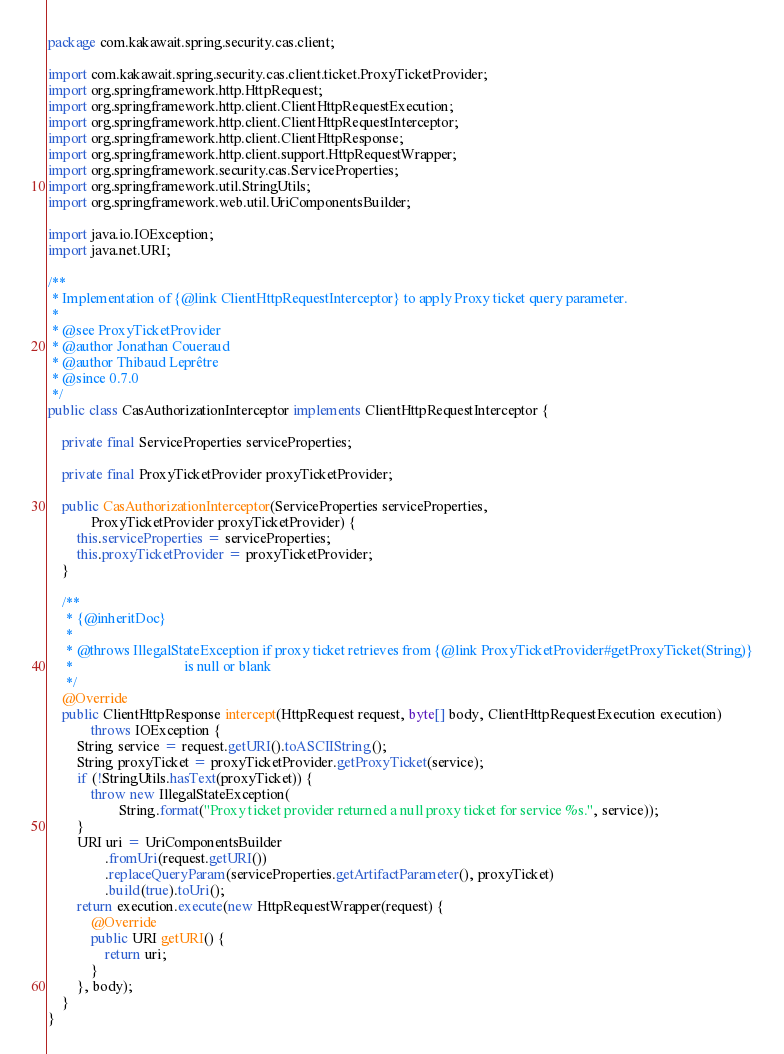<code> <loc_0><loc_0><loc_500><loc_500><_Java_>package com.kakawait.spring.security.cas.client;

import com.kakawait.spring.security.cas.client.ticket.ProxyTicketProvider;
import org.springframework.http.HttpRequest;
import org.springframework.http.client.ClientHttpRequestExecution;
import org.springframework.http.client.ClientHttpRequestInterceptor;
import org.springframework.http.client.ClientHttpResponse;
import org.springframework.http.client.support.HttpRequestWrapper;
import org.springframework.security.cas.ServiceProperties;
import org.springframework.util.StringUtils;
import org.springframework.web.util.UriComponentsBuilder;

import java.io.IOException;
import java.net.URI;

/**
 * Implementation of {@link ClientHttpRequestInterceptor} to apply Proxy ticket query parameter.
 *
 * @see ProxyTicketProvider
 * @author Jonathan Coueraud
 * @author Thibaud Leprêtre
 * @since 0.7.0
 */
public class CasAuthorizationInterceptor implements ClientHttpRequestInterceptor {

    private final ServiceProperties serviceProperties;

    private final ProxyTicketProvider proxyTicketProvider;

    public CasAuthorizationInterceptor(ServiceProperties serviceProperties,
            ProxyTicketProvider proxyTicketProvider) {
        this.serviceProperties = serviceProperties;
        this.proxyTicketProvider = proxyTicketProvider;
    }

    /**
     * {@inheritDoc}
     *
     * @throws IllegalStateException if proxy ticket retrieves from {@link ProxyTicketProvider#getProxyTicket(String)}
     *                               is null or blank
     */
    @Override
    public ClientHttpResponse intercept(HttpRequest request, byte[] body, ClientHttpRequestExecution execution)
            throws IOException {
        String service = request.getURI().toASCIIString();
        String proxyTicket = proxyTicketProvider.getProxyTicket(service);
        if (!StringUtils.hasText(proxyTicket)) {
            throw new IllegalStateException(
                    String.format("Proxy ticket provider returned a null proxy ticket for service %s.", service));
        }
        URI uri = UriComponentsBuilder
                .fromUri(request.getURI())
                .replaceQueryParam(serviceProperties.getArtifactParameter(), proxyTicket)
                .build(true).toUri();
        return execution.execute(new HttpRequestWrapper(request) {
            @Override
            public URI getURI() {
                return uri;
            }
        }, body);
    }
}
</code> 